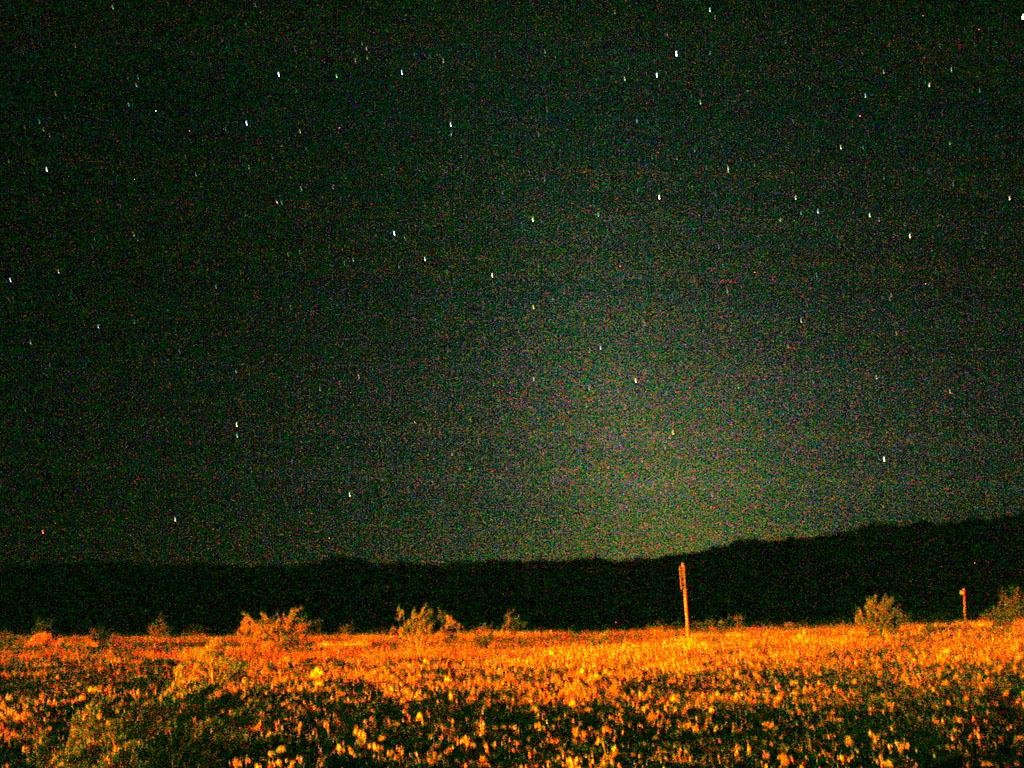What time of day is depicted in the image? The image depicts a night view. What type of surface is visible in the foreground of the image? There is a grass surface with plants in the image. What can be seen in the distance in the image? There are hills visible in the distance. How are the hills illuminated in the image? The hills are in a dark setting. What is visible above the hills in the image? The sky is visible in the image. What celestial objects can be seen in the sky? Stars are present in the sky. Reasoning: Let's think step by step by breaking down the image into its main components. We start by identifying the time of day, which is night, based on the facts provided. Then, we describe the foreground, which consists of a grass surface with plants. Next, we move to the background, where we see hills and a dark setting. We also mention the sky and the presence of stars. Each question is designed to elicit a specific detail about the image that is known from the provided facts. Absurd Question/Answer: What type of throat lozenge is visible in the image? There is no throat lozenge present in the image. What is the purpose of the tin in the image? There is no tin present in the image. How many screws can be seen holding the structure together in the image? There is no structure or screws present in the image. 